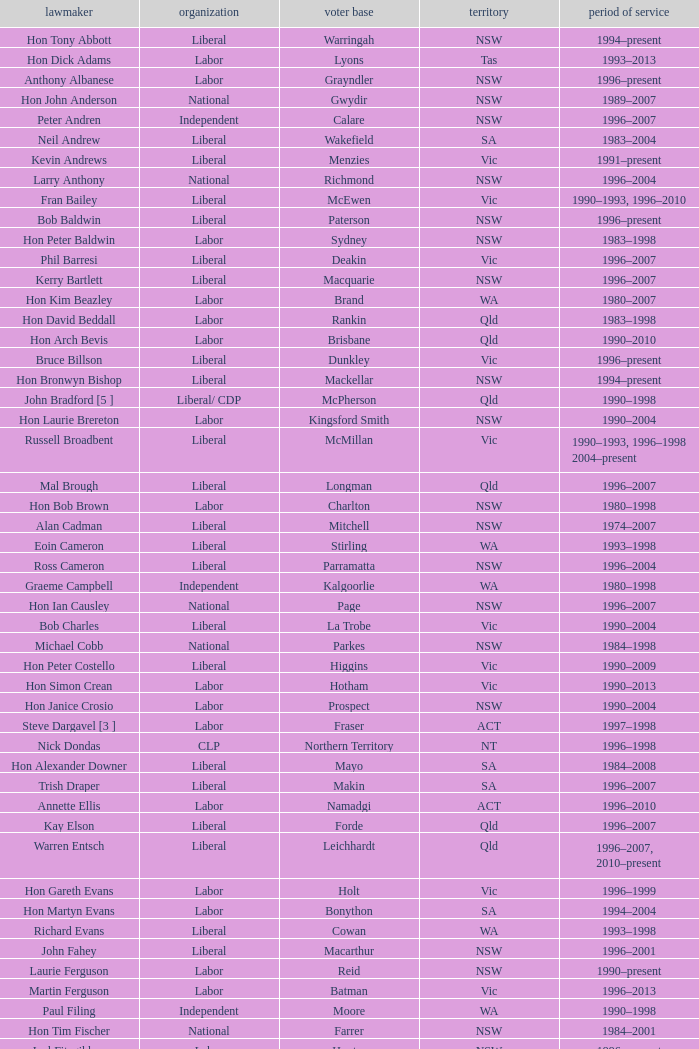What state did Hon David Beddall belong to? Qld. 